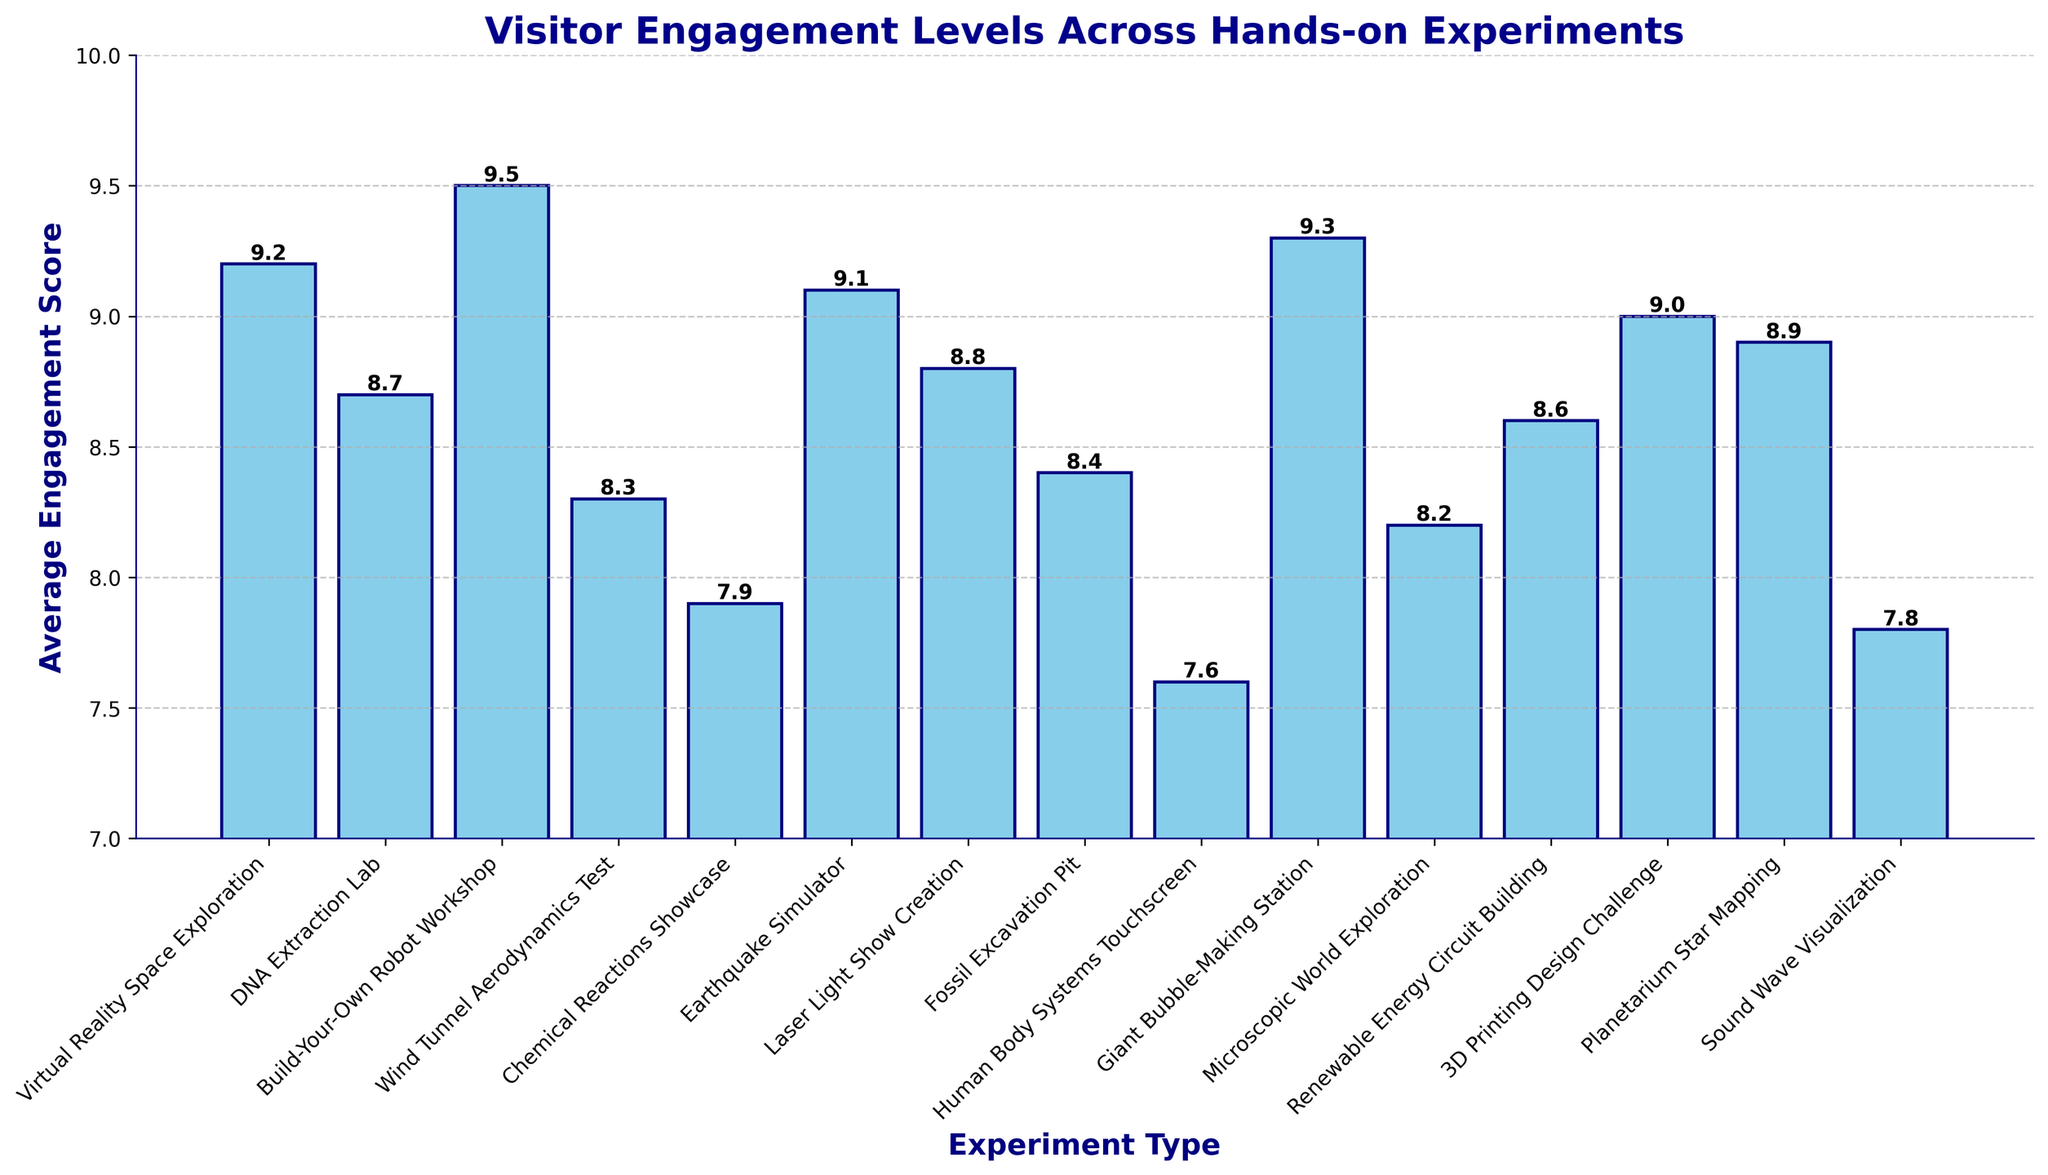What's the highest engagement score across all hands-on experiments? Look for the tallest bar in the chart, which represents the highest engagement score. The 'Build-Your-Own Robot Workshop' has the highest bar with a score of 9.5.
Answer: 9.5 Which hands-on experiment has the lowest engagement score? Look for the shortest bar in the chart, which represents the lowest engagement score. The 'Human Body Systems Touchscreen' has the shortest bar with a score of 7.6.
Answer: Human Body Systems Touchscreen What's the difference in engagement scores between the 'Wind Tunnel Aerodynamics Test' and the 'Laser Light Show Creation'? Find the engagement scores for both experiments from the bars. Wind Tunnel Aerodynamics Test has a score of 8.3, and Laser Light Show Creation has 8.8. Subtract 8.3 from 8.8 to get the difference, which is 0.5.
Answer: 0.5 How many hands-on experiments have an engagement score greater than 9? Count the bars that have a height greater than 9. The experiments are: 'Virtual Reality Space Exploration', 'Build-Your-Own Robot Workshop', 'Giant Bubble-Making Station', and 'Earthquake Simulator'. There are 4 such experiments.
Answer: 4 Which experiment has a higher engagement score: 'Chemical Reactions Showcase' or '3D Printing Design Challenge'? Compare the heights of the bars for these experiments. 'Chemical Reactions Showcase' has a score of 7.9, while '3D Printing Design Challenge' has a score of 9.0. 9.0 is higher than 7.9.
Answer: 3D Printing Design Challenge What is the average engagement score for 'Virtual Reality Space Exploration', 'Earthquake Simulator', and 'Giant Bubble-Making Station'? Find the engagement scores: 'Virtual Reality Space Exploration' is 9.2, 'Earthquake Simulator' is 9.1, and 'Giant Bubble-Making Station' is 9.3. Add these scores (9.2+9.1+9.3) to get 27.6, then divide by 3 to get the average, which is 9.2.
Answer: 9.2 What is the total engagement score for the 'Human Body Systems Touchscreen' and 'Sound Wave Visualization'? Find the engagement scores: 'Human Body Systems Touchscreen' is 7.6, and 'Sound Wave Visualization' is 7.8. Add these scores (7.6+7.8) to get a total of 15.4.
Answer: 15.4 Which experiment type has a noticeably light blue shade on the chart? Identify the color used for the bars, which is light blue for all bars on the chart. No single experiment has a unique light blue color as all the bars share the same light blue shade.
Answer: All experiments Sort the engagement scores for 'Microscopic World Exploration', 'Renewable Energy Circuit Building', and 'Planetarium Star Mapping' in descending order. Find the engagement scores: 'Microscopic World Exploration' is 8.2, 'Renewable Energy Circuit Building' is 8.6, and 'Planetarium Star Mapping' is 8.9. Arranging them in descending order gives 8.9, 8.6, 8.2.
Answer: 8.9, 8.6, 8.2 What's the median engagement score among all experiments? List the engagement scores in ascending order: 7.6, 7.8, 7.9, 8.2, 8.3, 8.4, 8.6, 8.7, 8.8, 8.9, 9.0, 9.1, 9.2, 9.3, 9.5. The middle value in this ordered list (15 values) is the 8th one, which corresponds to 8.7.
Answer: 8.7 